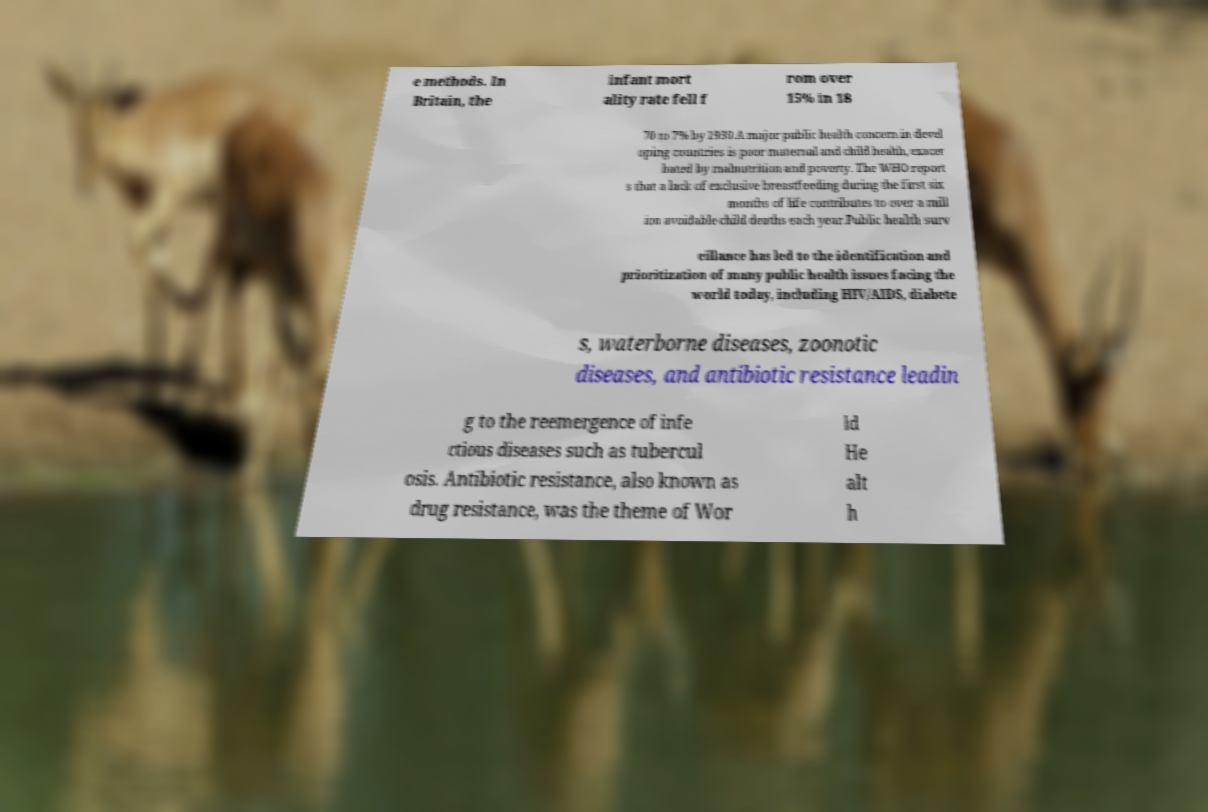Please read and relay the text visible in this image. What does it say? e methods. In Britain, the infant mort ality rate fell f rom over 15% in 18 70 to 7% by 1930.A major public health concern in devel oping countries is poor maternal and child health, exacer bated by malnutrition and poverty. The WHO report s that a lack of exclusive breastfeeding during the first six months of life contributes to over a mill ion avoidable child deaths each year.Public health surv eillance has led to the identification and prioritization of many public health issues facing the world today, including HIV/AIDS, diabete s, waterborne diseases, zoonotic diseases, and antibiotic resistance leadin g to the reemergence of infe ctious diseases such as tubercul osis. Antibiotic resistance, also known as drug resistance, was the theme of Wor ld He alt h 